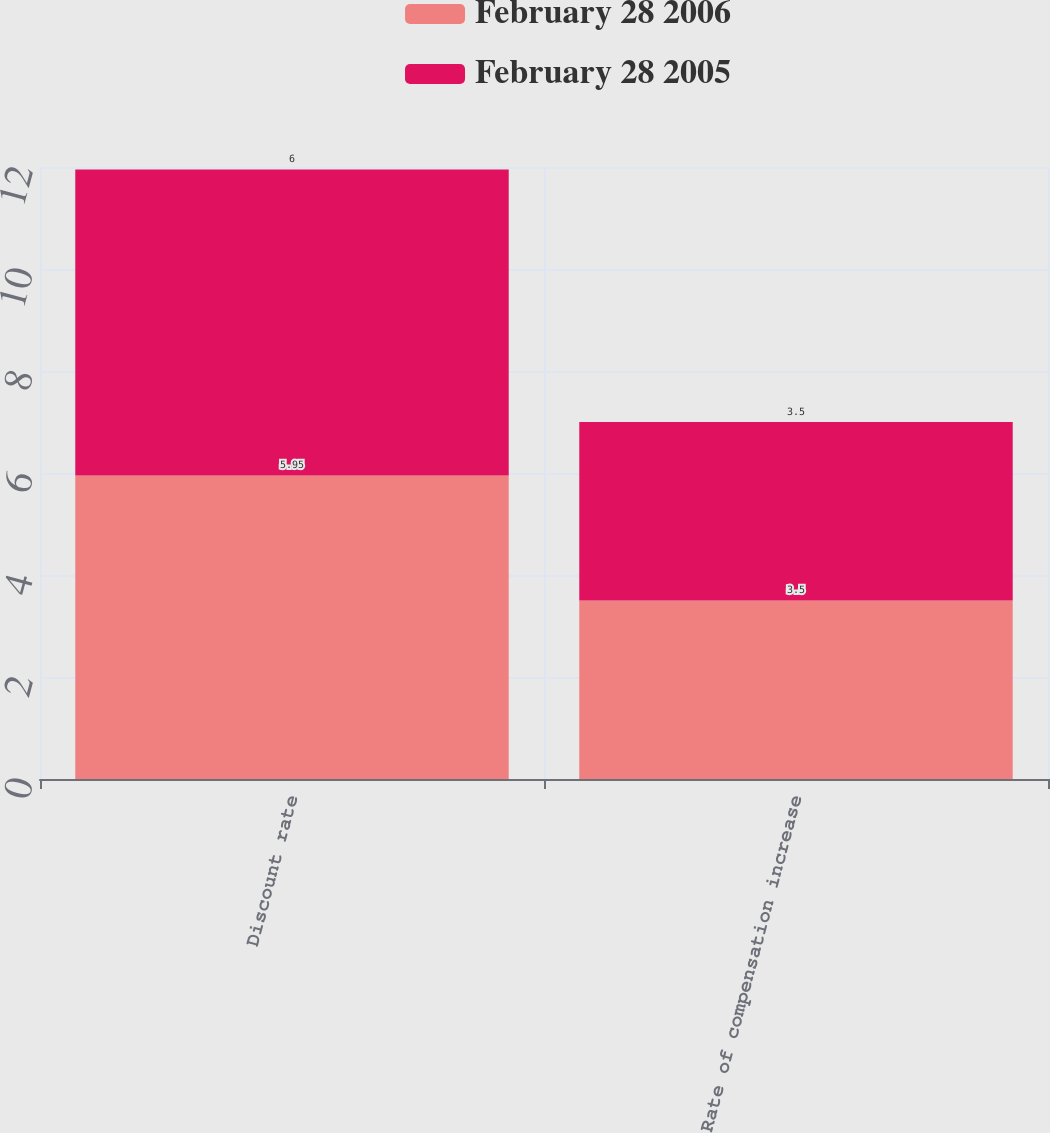<chart> <loc_0><loc_0><loc_500><loc_500><stacked_bar_chart><ecel><fcel>Discount rate<fcel>Rate of compensation increase<nl><fcel>February 28 2006<fcel>5.95<fcel>3.5<nl><fcel>February 28 2005<fcel>6<fcel>3.5<nl></chart> 